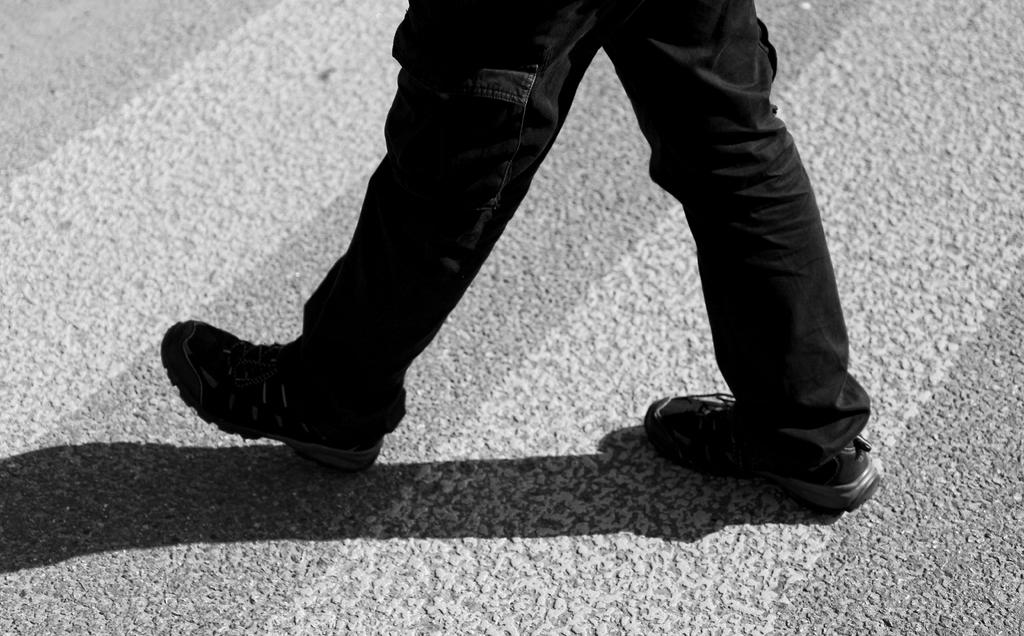What is visible in the foreground of the image? There are legs of a person in the foreground of the image. Where are the legs located? The legs are on the road. What type of celery can be seen growing on the person's toes in the image? There is no celery present in the image, and the person's toes are not visible. 